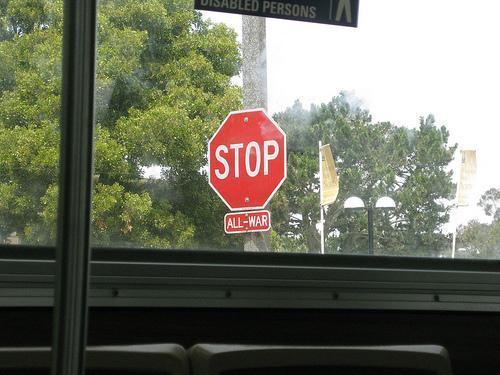How many banners are seen?
Give a very brief answer. 2. How many seat backs are seen?
Give a very brief answer. 2. 